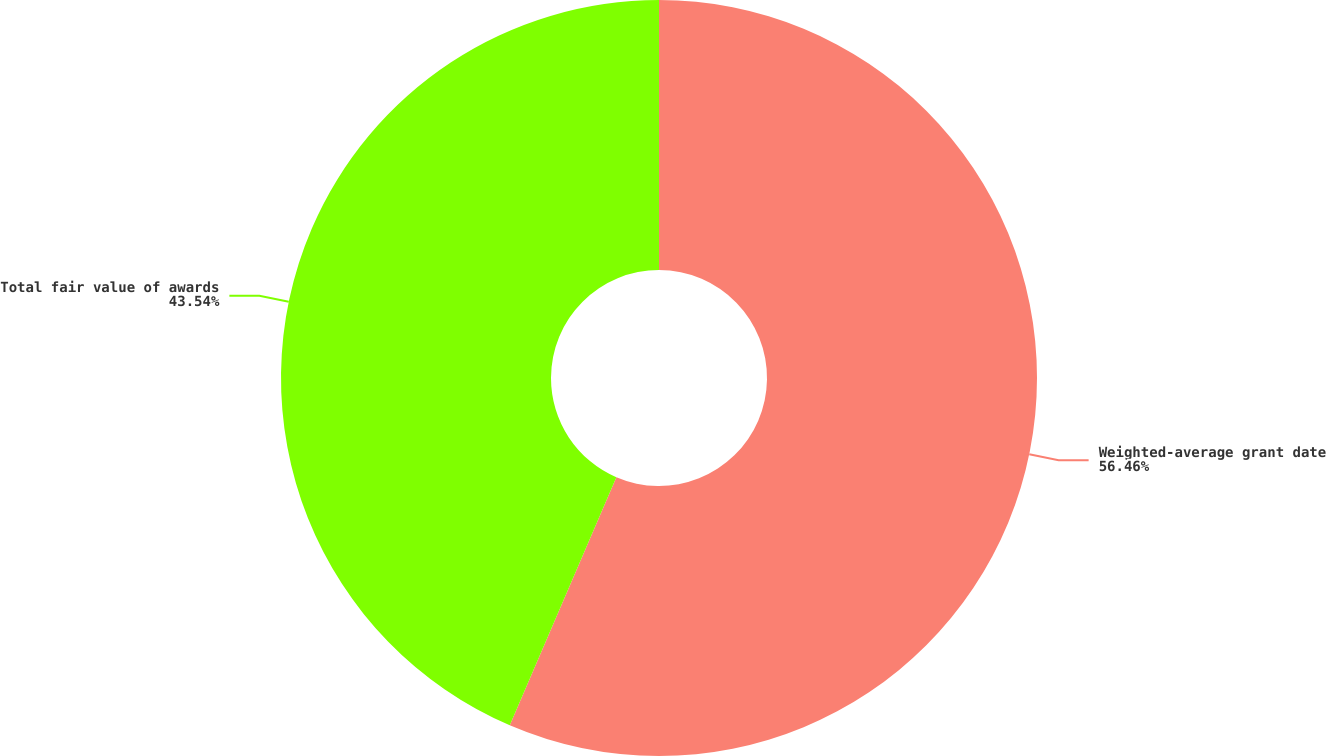<chart> <loc_0><loc_0><loc_500><loc_500><pie_chart><fcel>Weighted-average grant date<fcel>Total fair value of awards<nl><fcel>56.46%<fcel>43.54%<nl></chart> 